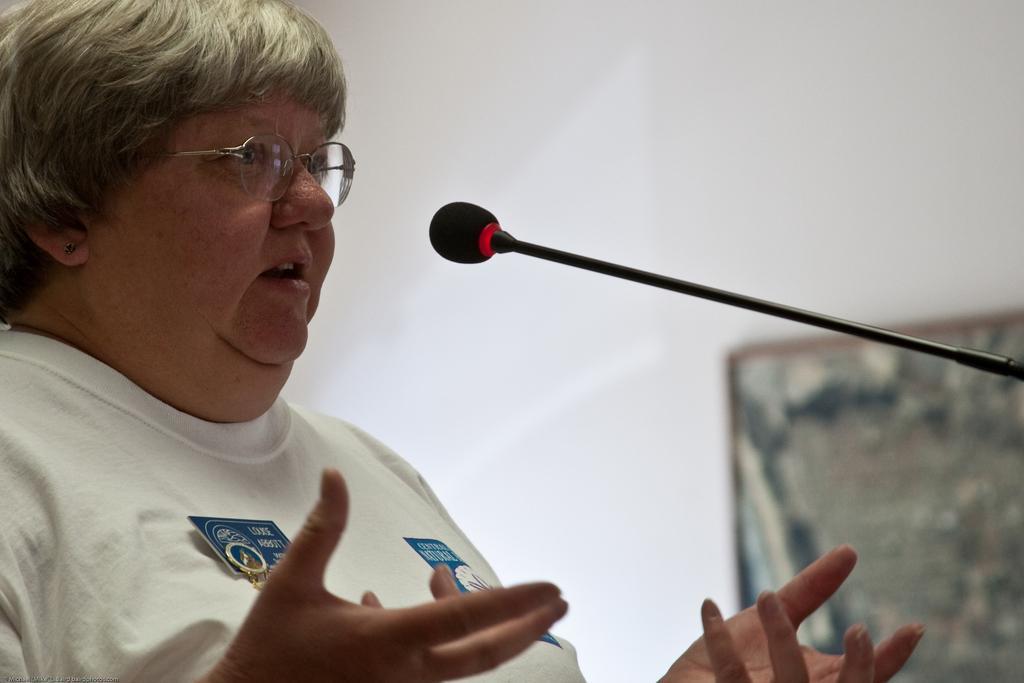Describe this image in one or two sentences. In this picture I can see a person with spectacles, there is a mike, and in the background there is a frame attached to the wall. 